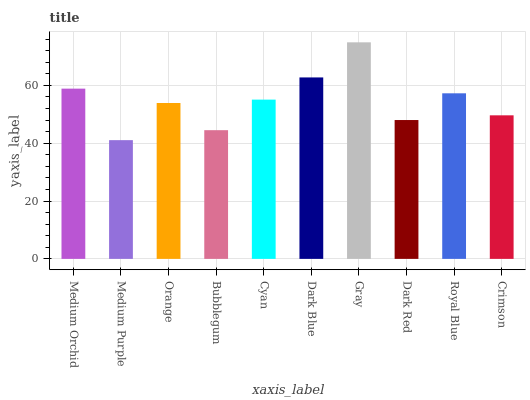Is Orange the minimum?
Answer yes or no. No. Is Orange the maximum?
Answer yes or no. No. Is Orange greater than Medium Purple?
Answer yes or no. Yes. Is Medium Purple less than Orange?
Answer yes or no. Yes. Is Medium Purple greater than Orange?
Answer yes or no. No. Is Orange less than Medium Purple?
Answer yes or no. No. Is Cyan the high median?
Answer yes or no. Yes. Is Orange the low median?
Answer yes or no. Yes. Is Royal Blue the high median?
Answer yes or no. No. Is Medium Orchid the low median?
Answer yes or no. No. 